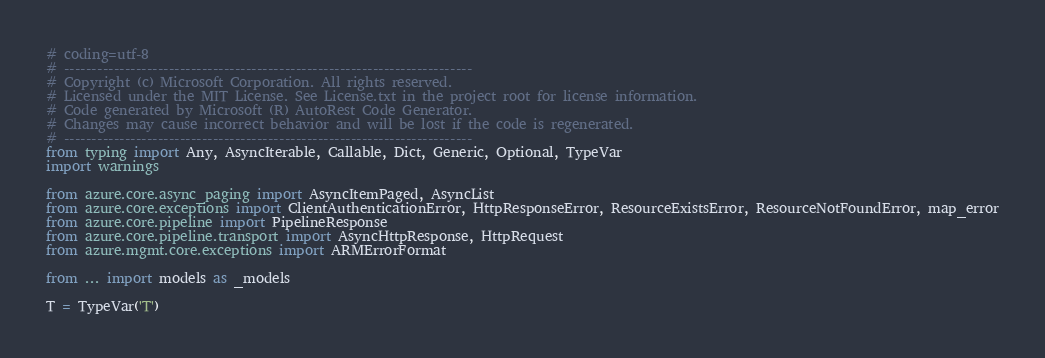<code> <loc_0><loc_0><loc_500><loc_500><_Python_># coding=utf-8
# --------------------------------------------------------------------------
# Copyright (c) Microsoft Corporation. All rights reserved.
# Licensed under the MIT License. See License.txt in the project root for license information.
# Code generated by Microsoft (R) AutoRest Code Generator.
# Changes may cause incorrect behavior and will be lost if the code is regenerated.
# --------------------------------------------------------------------------
from typing import Any, AsyncIterable, Callable, Dict, Generic, Optional, TypeVar
import warnings

from azure.core.async_paging import AsyncItemPaged, AsyncList
from azure.core.exceptions import ClientAuthenticationError, HttpResponseError, ResourceExistsError, ResourceNotFoundError, map_error
from azure.core.pipeline import PipelineResponse
from azure.core.pipeline.transport import AsyncHttpResponse, HttpRequest
from azure.mgmt.core.exceptions import ARMErrorFormat

from ... import models as _models

T = TypeVar('T')</code> 